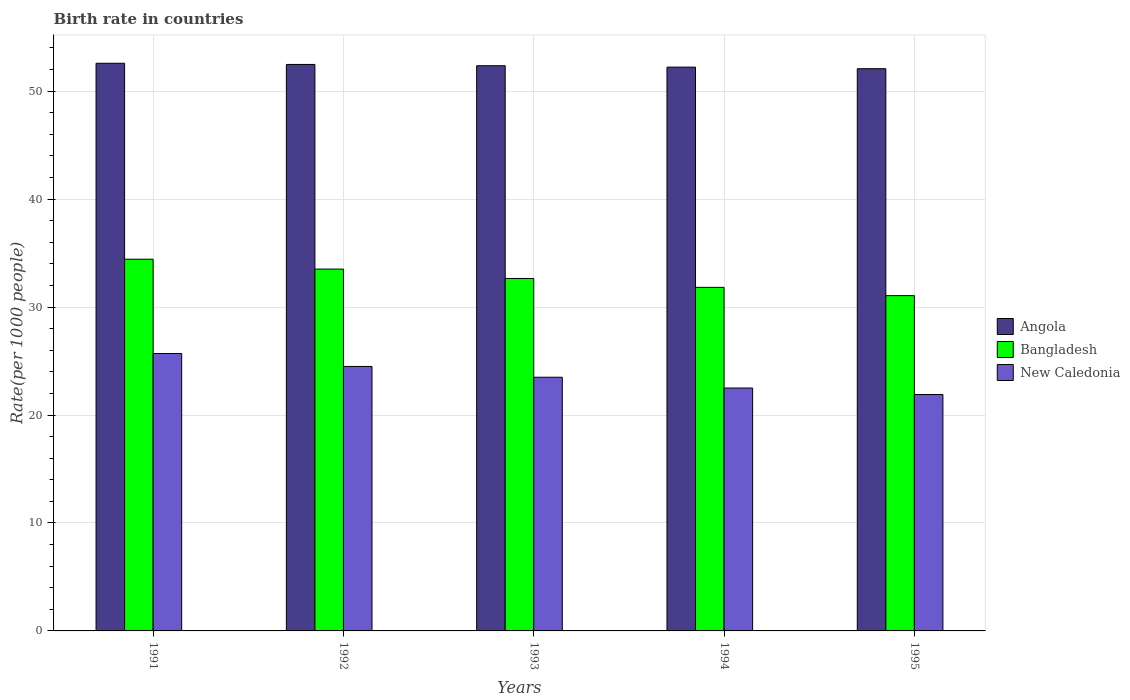Are the number of bars per tick equal to the number of legend labels?
Your response must be concise. Yes. What is the birth rate in New Caledonia in 1995?
Provide a succinct answer. 21.9. Across all years, what is the maximum birth rate in Bangladesh?
Offer a very short reply. 34.43. Across all years, what is the minimum birth rate in Angola?
Your answer should be very brief. 52.08. In which year was the birth rate in Bangladesh maximum?
Your response must be concise. 1991. In which year was the birth rate in Bangladesh minimum?
Provide a short and direct response. 1995. What is the total birth rate in Bangladesh in the graph?
Your answer should be very brief. 163.48. What is the difference between the birth rate in Bangladesh in 1991 and that in 1995?
Ensure brevity in your answer.  3.38. What is the difference between the birth rate in Bangladesh in 1993 and the birth rate in New Caledonia in 1995?
Your answer should be very brief. 10.75. What is the average birth rate in New Caledonia per year?
Offer a very short reply. 23.62. In the year 1992, what is the difference between the birth rate in Bangladesh and birth rate in New Caledonia?
Keep it short and to the point. 9.02. In how many years, is the birth rate in Angola greater than 44?
Make the answer very short. 5. What is the ratio of the birth rate in New Caledonia in 1994 to that in 1995?
Ensure brevity in your answer.  1.03. What is the difference between the highest and the second highest birth rate in New Caledonia?
Keep it short and to the point. 1.2. What is the difference between the highest and the lowest birth rate in Angola?
Keep it short and to the point. 0.5. What does the 3rd bar from the left in 1994 represents?
Provide a succinct answer. New Caledonia. Is it the case that in every year, the sum of the birth rate in Angola and birth rate in Bangladesh is greater than the birth rate in New Caledonia?
Give a very brief answer. Yes. What is the difference between two consecutive major ticks on the Y-axis?
Offer a terse response. 10. Does the graph contain any zero values?
Make the answer very short. No. Does the graph contain grids?
Ensure brevity in your answer.  Yes. How many legend labels are there?
Provide a succinct answer. 3. How are the legend labels stacked?
Give a very brief answer. Vertical. What is the title of the graph?
Keep it short and to the point. Birth rate in countries. What is the label or title of the X-axis?
Your answer should be compact. Years. What is the label or title of the Y-axis?
Ensure brevity in your answer.  Rate(per 1000 people). What is the Rate(per 1000 people) of Angola in 1991?
Your answer should be compact. 52.59. What is the Rate(per 1000 people) in Bangladesh in 1991?
Offer a terse response. 34.43. What is the Rate(per 1000 people) of New Caledonia in 1991?
Your answer should be compact. 25.7. What is the Rate(per 1000 people) in Angola in 1992?
Keep it short and to the point. 52.48. What is the Rate(per 1000 people) of Bangladesh in 1992?
Make the answer very short. 33.52. What is the Rate(per 1000 people) of New Caledonia in 1992?
Keep it short and to the point. 24.5. What is the Rate(per 1000 people) of Angola in 1993?
Ensure brevity in your answer.  52.36. What is the Rate(per 1000 people) in Bangladesh in 1993?
Your answer should be compact. 32.65. What is the Rate(per 1000 people) in Angola in 1994?
Provide a succinct answer. 52.23. What is the Rate(per 1000 people) in Bangladesh in 1994?
Provide a succinct answer. 31.83. What is the Rate(per 1000 people) in Angola in 1995?
Your response must be concise. 52.08. What is the Rate(per 1000 people) of Bangladesh in 1995?
Ensure brevity in your answer.  31.06. What is the Rate(per 1000 people) in New Caledonia in 1995?
Your answer should be very brief. 21.9. Across all years, what is the maximum Rate(per 1000 people) of Angola?
Your answer should be compact. 52.59. Across all years, what is the maximum Rate(per 1000 people) of Bangladesh?
Make the answer very short. 34.43. Across all years, what is the maximum Rate(per 1000 people) of New Caledonia?
Give a very brief answer. 25.7. Across all years, what is the minimum Rate(per 1000 people) of Angola?
Provide a succinct answer. 52.08. Across all years, what is the minimum Rate(per 1000 people) in Bangladesh?
Provide a short and direct response. 31.06. Across all years, what is the minimum Rate(per 1000 people) of New Caledonia?
Ensure brevity in your answer.  21.9. What is the total Rate(per 1000 people) in Angola in the graph?
Provide a succinct answer. 261.73. What is the total Rate(per 1000 people) of Bangladesh in the graph?
Offer a very short reply. 163.48. What is the total Rate(per 1000 people) in New Caledonia in the graph?
Make the answer very short. 118.1. What is the difference between the Rate(per 1000 people) in Angola in 1991 and that in 1992?
Ensure brevity in your answer.  0.11. What is the difference between the Rate(per 1000 people) of Bangladesh in 1991 and that in 1992?
Give a very brief answer. 0.91. What is the difference between the Rate(per 1000 people) of New Caledonia in 1991 and that in 1992?
Your response must be concise. 1.2. What is the difference between the Rate(per 1000 people) in Angola in 1991 and that in 1993?
Your response must be concise. 0.23. What is the difference between the Rate(per 1000 people) in Bangladesh in 1991 and that in 1993?
Make the answer very short. 1.78. What is the difference between the Rate(per 1000 people) of Angola in 1991 and that in 1994?
Make the answer very short. 0.36. What is the difference between the Rate(per 1000 people) in Bangladesh in 1991 and that in 1994?
Ensure brevity in your answer.  2.61. What is the difference between the Rate(per 1000 people) of New Caledonia in 1991 and that in 1994?
Make the answer very short. 3.2. What is the difference between the Rate(per 1000 people) of Angola in 1991 and that in 1995?
Ensure brevity in your answer.  0.5. What is the difference between the Rate(per 1000 people) of Bangladesh in 1991 and that in 1995?
Provide a short and direct response. 3.38. What is the difference between the Rate(per 1000 people) of New Caledonia in 1991 and that in 1995?
Give a very brief answer. 3.8. What is the difference between the Rate(per 1000 people) in Angola in 1992 and that in 1993?
Your response must be concise. 0.12. What is the difference between the Rate(per 1000 people) in Bangladesh in 1992 and that in 1993?
Make the answer very short. 0.87. What is the difference between the Rate(per 1000 people) in Angola in 1992 and that in 1994?
Offer a terse response. 0.25. What is the difference between the Rate(per 1000 people) in Bangladesh in 1992 and that in 1994?
Ensure brevity in your answer.  1.69. What is the difference between the Rate(per 1000 people) in New Caledonia in 1992 and that in 1994?
Offer a terse response. 2. What is the difference between the Rate(per 1000 people) of Angola in 1992 and that in 1995?
Your response must be concise. 0.39. What is the difference between the Rate(per 1000 people) of Bangladesh in 1992 and that in 1995?
Offer a terse response. 2.46. What is the difference between the Rate(per 1000 people) of New Caledonia in 1992 and that in 1995?
Your response must be concise. 2.6. What is the difference between the Rate(per 1000 people) of Angola in 1993 and that in 1994?
Your answer should be compact. 0.13. What is the difference between the Rate(per 1000 people) of Bangladesh in 1993 and that in 1994?
Your response must be concise. 0.82. What is the difference between the Rate(per 1000 people) in New Caledonia in 1993 and that in 1994?
Your answer should be very brief. 1. What is the difference between the Rate(per 1000 people) in Angola in 1993 and that in 1995?
Make the answer very short. 0.28. What is the difference between the Rate(per 1000 people) of Bangladesh in 1993 and that in 1995?
Your answer should be very brief. 1.59. What is the difference between the Rate(per 1000 people) in Angola in 1994 and that in 1995?
Keep it short and to the point. 0.15. What is the difference between the Rate(per 1000 people) in Bangladesh in 1994 and that in 1995?
Your answer should be very brief. 0.77. What is the difference between the Rate(per 1000 people) of New Caledonia in 1994 and that in 1995?
Your answer should be compact. 0.6. What is the difference between the Rate(per 1000 people) in Angola in 1991 and the Rate(per 1000 people) in Bangladesh in 1992?
Offer a terse response. 19.07. What is the difference between the Rate(per 1000 people) in Angola in 1991 and the Rate(per 1000 people) in New Caledonia in 1992?
Ensure brevity in your answer.  28.09. What is the difference between the Rate(per 1000 people) of Bangladesh in 1991 and the Rate(per 1000 people) of New Caledonia in 1992?
Your response must be concise. 9.93. What is the difference between the Rate(per 1000 people) of Angola in 1991 and the Rate(per 1000 people) of Bangladesh in 1993?
Make the answer very short. 19.94. What is the difference between the Rate(per 1000 people) in Angola in 1991 and the Rate(per 1000 people) in New Caledonia in 1993?
Your answer should be very brief. 29.09. What is the difference between the Rate(per 1000 people) of Bangladesh in 1991 and the Rate(per 1000 people) of New Caledonia in 1993?
Your answer should be compact. 10.93. What is the difference between the Rate(per 1000 people) of Angola in 1991 and the Rate(per 1000 people) of Bangladesh in 1994?
Your answer should be compact. 20.76. What is the difference between the Rate(per 1000 people) of Angola in 1991 and the Rate(per 1000 people) of New Caledonia in 1994?
Provide a short and direct response. 30.09. What is the difference between the Rate(per 1000 people) in Bangladesh in 1991 and the Rate(per 1000 people) in New Caledonia in 1994?
Provide a short and direct response. 11.93. What is the difference between the Rate(per 1000 people) of Angola in 1991 and the Rate(per 1000 people) of Bangladesh in 1995?
Your response must be concise. 21.53. What is the difference between the Rate(per 1000 people) in Angola in 1991 and the Rate(per 1000 people) in New Caledonia in 1995?
Your answer should be compact. 30.68. What is the difference between the Rate(per 1000 people) in Bangladesh in 1991 and the Rate(per 1000 people) in New Caledonia in 1995?
Your answer should be very brief. 12.53. What is the difference between the Rate(per 1000 people) in Angola in 1992 and the Rate(per 1000 people) in Bangladesh in 1993?
Make the answer very short. 19.83. What is the difference between the Rate(per 1000 people) in Angola in 1992 and the Rate(per 1000 people) in New Caledonia in 1993?
Give a very brief answer. 28.98. What is the difference between the Rate(per 1000 people) of Bangladesh in 1992 and the Rate(per 1000 people) of New Caledonia in 1993?
Offer a very short reply. 10.02. What is the difference between the Rate(per 1000 people) of Angola in 1992 and the Rate(per 1000 people) of Bangladesh in 1994?
Make the answer very short. 20.65. What is the difference between the Rate(per 1000 people) of Angola in 1992 and the Rate(per 1000 people) of New Caledonia in 1994?
Your answer should be very brief. 29.98. What is the difference between the Rate(per 1000 people) of Bangladesh in 1992 and the Rate(per 1000 people) of New Caledonia in 1994?
Offer a very short reply. 11.02. What is the difference between the Rate(per 1000 people) of Angola in 1992 and the Rate(per 1000 people) of Bangladesh in 1995?
Offer a terse response. 21.42. What is the difference between the Rate(per 1000 people) in Angola in 1992 and the Rate(per 1000 people) in New Caledonia in 1995?
Keep it short and to the point. 30.57. What is the difference between the Rate(per 1000 people) in Bangladesh in 1992 and the Rate(per 1000 people) in New Caledonia in 1995?
Give a very brief answer. 11.62. What is the difference between the Rate(per 1000 people) in Angola in 1993 and the Rate(per 1000 people) in Bangladesh in 1994?
Offer a terse response. 20.53. What is the difference between the Rate(per 1000 people) in Angola in 1993 and the Rate(per 1000 people) in New Caledonia in 1994?
Make the answer very short. 29.86. What is the difference between the Rate(per 1000 people) of Bangladesh in 1993 and the Rate(per 1000 people) of New Caledonia in 1994?
Keep it short and to the point. 10.15. What is the difference between the Rate(per 1000 people) in Angola in 1993 and the Rate(per 1000 people) in Bangladesh in 1995?
Give a very brief answer. 21.3. What is the difference between the Rate(per 1000 people) in Angola in 1993 and the Rate(per 1000 people) in New Caledonia in 1995?
Provide a short and direct response. 30.46. What is the difference between the Rate(per 1000 people) of Bangladesh in 1993 and the Rate(per 1000 people) of New Caledonia in 1995?
Ensure brevity in your answer.  10.75. What is the difference between the Rate(per 1000 people) in Angola in 1994 and the Rate(per 1000 people) in Bangladesh in 1995?
Keep it short and to the point. 21.17. What is the difference between the Rate(per 1000 people) in Angola in 1994 and the Rate(per 1000 people) in New Caledonia in 1995?
Your response must be concise. 30.33. What is the difference between the Rate(per 1000 people) of Bangladesh in 1994 and the Rate(per 1000 people) of New Caledonia in 1995?
Provide a short and direct response. 9.93. What is the average Rate(per 1000 people) of Angola per year?
Keep it short and to the point. 52.34. What is the average Rate(per 1000 people) in Bangladesh per year?
Make the answer very short. 32.7. What is the average Rate(per 1000 people) in New Caledonia per year?
Your answer should be compact. 23.62. In the year 1991, what is the difference between the Rate(per 1000 people) in Angola and Rate(per 1000 people) in Bangladesh?
Offer a very short reply. 18.15. In the year 1991, what is the difference between the Rate(per 1000 people) in Angola and Rate(per 1000 people) in New Caledonia?
Give a very brief answer. 26.89. In the year 1991, what is the difference between the Rate(per 1000 people) in Bangladesh and Rate(per 1000 people) in New Caledonia?
Offer a very short reply. 8.73. In the year 1992, what is the difference between the Rate(per 1000 people) in Angola and Rate(per 1000 people) in Bangladesh?
Your response must be concise. 18.96. In the year 1992, what is the difference between the Rate(per 1000 people) in Angola and Rate(per 1000 people) in New Caledonia?
Offer a very short reply. 27.98. In the year 1992, what is the difference between the Rate(per 1000 people) of Bangladesh and Rate(per 1000 people) of New Caledonia?
Your response must be concise. 9.02. In the year 1993, what is the difference between the Rate(per 1000 people) of Angola and Rate(per 1000 people) of Bangladesh?
Provide a succinct answer. 19.71. In the year 1993, what is the difference between the Rate(per 1000 people) in Angola and Rate(per 1000 people) in New Caledonia?
Provide a succinct answer. 28.86. In the year 1993, what is the difference between the Rate(per 1000 people) of Bangladesh and Rate(per 1000 people) of New Caledonia?
Your answer should be compact. 9.15. In the year 1994, what is the difference between the Rate(per 1000 people) in Angola and Rate(per 1000 people) in Bangladesh?
Provide a short and direct response. 20.4. In the year 1994, what is the difference between the Rate(per 1000 people) of Angola and Rate(per 1000 people) of New Caledonia?
Your answer should be very brief. 29.73. In the year 1994, what is the difference between the Rate(per 1000 people) of Bangladesh and Rate(per 1000 people) of New Caledonia?
Provide a short and direct response. 9.33. In the year 1995, what is the difference between the Rate(per 1000 people) of Angola and Rate(per 1000 people) of Bangladesh?
Offer a terse response. 21.02. In the year 1995, what is the difference between the Rate(per 1000 people) in Angola and Rate(per 1000 people) in New Caledonia?
Offer a very short reply. 30.18. In the year 1995, what is the difference between the Rate(per 1000 people) of Bangladesh and Rate(per 1000 people) of New Caledonia?
Give a very brief answer. 9.16. What is the ratio of the Rate(per 1000 people) of Angola in 1991 to that in 1992?
Your answer should be compact. 1. What is the ratio of the Rate(per 1000 people) of Bangladesh in 1991 to that in 1992?
Keep it short and to the point. 1.03. What is the ratio of the Rate(per 1000 people) in New Caledonia in 1991 to that in 1992?
Give a very brief answer. 1.05. What is the ratio of the Rate(per 1000 people) of Bangladesh in 1991 to that in 1993?
Provide a succinct answer. 1.05. What is the ratio of the Rate(per 1000 people) of New Caledonia in 1991 to that in 1993?
Your answer should be very brief. 1.09. What is the ratio of the Rate(per 1000 people) in Bangladesh in 1991 to that in 1994?
Make the answer very short. 1.08. What is the ratio of the Rate(per 1000 people) of New Caledonia in 1991 to that in 1994?
Make the answer very short. 1.14. What is the ratio of the Rate(per 1000 people) in Angola in 1991 to that in 1995?
Your answer should be very brief. 1.01. What is the ratio of the Rate(per 1000 people) in Bangladesh in 1991 to that in 1995?
Your answer should be compact. 1.11. What is the ratio of the Rate(per 1000 people) of New Caledonia in 1991 to that in 1995?
Provide a succinct answer. 1.17. What is the ratio of the Rate(per 1000 people) of Angola in 1992 to that in 1993?
Give a very brief answer. 1. What is the ratio of the Rate(per 1000 people) in Bangladesh in 1992 to that in 1993?
Provide a succinct answer. 1.03. What is the ratio of the Rate(per 1000 people) in New Caledonia in 1992 to that in 1993?
Provide a succinct answer. 1.04. What is the ratio of the Rate(per 1000 people) of Angola in 1992 to that in 1994?
Your answer should be compact. 1. What is the ratio of the Rate(per 1000 people) in Bangladesh in 1992 to that in 1994?
Provide a succinct answer. 1.05. What is the ratio of the Rate(per 1000 people) of New Caledonia in 1992 to that in 1994?
Provide a short and direct response. 1.09. What is the ratio of the Rate(per 1000 people) in Angola in 1992 to that in 1995?
Provide a succinct answer. 1.01. What is the ratio of the Rate(per 1000 people) of Bangladesh in 1992 to that in 1995?
Ensure brevity in your answer.  1.08. What is the ratio of the Rate(per 1000 people) in New Caledonia in 1992 to that in 1995?
Provide a succinct answer. 1.12. What is the ratio of the Rate(per 1000 people) in Bangladesh in 1993 to that in 1994?
Your answer should be very brief. 1.03. What is the ratio of the Rate(per 1000 people) in New Caledonia in 1993 to that in 1994?
Make the answer very short. 1.04. What is the ratio of the Rate(per 1000 people) of Angola in 1993 to that in 1995?
Offer a terse response. 1.01. What is the ratio of the Rate(per 1000 people) of Bangladesh in 1993 to that in 1995?
Give a very brief answer. 1.05. What is the ratio of the Rate(per 1000 people) in New Caledonia in 1993 to that in 1995?
Your answer should be compact. 1.07. What is the ratio of the Rate(per 1000 people) of Bangladesh in 1994 to that in 1995?
Provide a succinct answer. 1.02. What is the ratio of the Rate(per 1000 people) in New Caledonia in 1994 to that in 1995?
Provide a succinct answer. 1.03. What is the difference between the highest and the second highest Rate(per 1000 people) of Angola?
Provide a succinct answer. 0.11. What is the difference between the highest and the second highest Rate(per 1000 people) in Bangladesh?
Your answer should be compact. 0.91. What is the difference between the highest and the lowest Rate(per 1000 people) of Angola?
Provide a short and direct response. 0.5. What is the difference between the highest and the lowest Rate(per 1000 people) of Bangladesh?
Your answer should be compact. 3.38. 